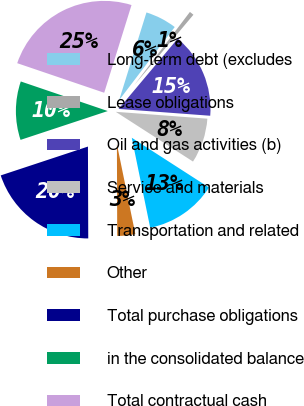<chart> <loc_0><loc_0><loc_500><loc_500><pie_chart><fcel>Long-term debt (excludes<fcel>Lease obligations<fcel>Oil and gas activities (b)<fcel>Service and materials<fcel>Transportation and related<fcel>Other<fcel>Total purchase obligations<fcel>in the consolidated balance<fcel>Total contractual cash<nl><fcel>5.54%<fcel>0.78%<fcel>15.06%<fcel>7.92%<fcel>12.68%<fcel>3.16%<fcel>19.97%<fcel>10.3%<fcel>24.59%<nl></chart> 